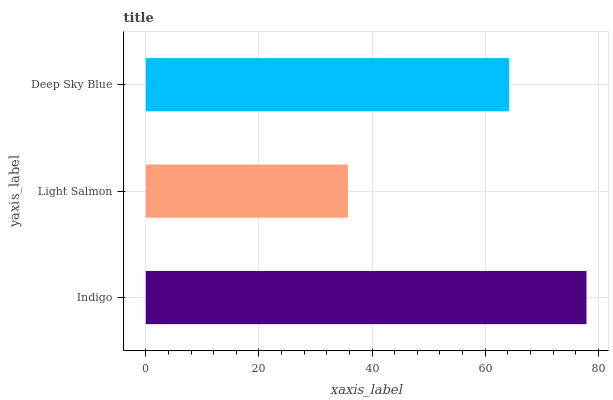Is Light Salmon the minimum?
Answer yes or no. Yes. Is Indigo the maximum?
Answer yes or no. Yes. Is Deep Sky Blue the minimum?
Answer yes or no. No. Is Deep Sky Blue the maximum?
Answer yes or no. No. Is Deep Sky Blue greater than Light Salmon?
Answer yes or no. Yes. Is Light Salmon less than Deep Sky Blue?
Answer yes or no. Yes. Is Light Salmon greater than Deep Sky Blue?
Answer yes or no. No. Is Deep Sky Blue less than Light Salmon?
Answer yes or no. No. Is Deep Sky Blue the high median?
Answer yes or no. Yes. Is Deep Sky Blue the low median?
Answer yes or no. Yes. Is Light Salmon the high median?
Answer yes or no. No. Is Light Salmon the low median?
Answer yes or no. No. 